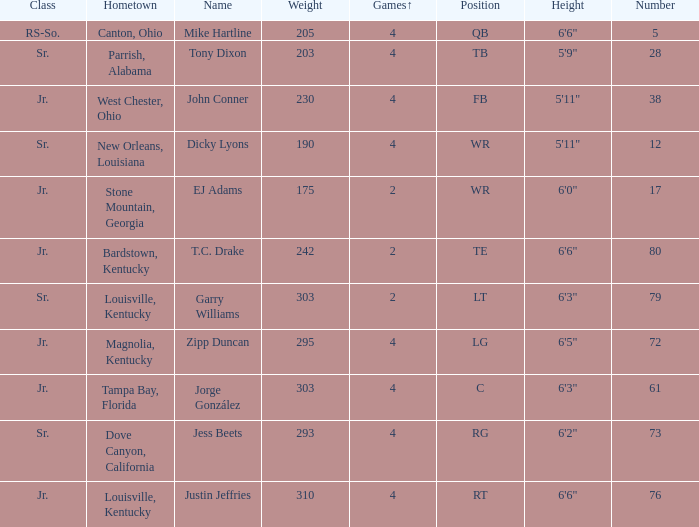Which Class has a Weight of 203? Sr. Write the full table. {'header': ['Class', 'Hometown', 'Name', 'Weight', 'Games↑', 'Position', 'Height', 'Number'], 'rows': [['RS-So.', 'Canton, Ohio', 'Mike Hartline', '205', '4', 'QB', '6\'6"', '5'], ['Sr.', 'Parrish, Alabama', 'Tony Dixon', '203', '4', 'TB', '5\'9"', '28'], ['Jr.', 'West Chester, Ohio', 'John Conner', '230', '4', 'FB', '5\'11"', '38'], ['Sr.', 'New Orleans, Louisiana', 'Dicky Lyons', '190', '4', 'WR', '5\'11"', '12'], ['Jr.', 'Stone Mountain, Georgia', 'EJ Adams', '175', '2', 'WR', '6\'0"', '17'], ['Jr.', 'Bardstown, Kentucky', 'T.C. Drake', '242', '2', 'TE', '6\'6"', '80'], ['Sr.', 'Louisville, Kentucky', 'Garry Williams', '303', '2', 'LT', '6\'3"', '79'], ['Jr.', 'Magnolia, Kentucky', 'Zipp Duncan', '295', '4', 'LG', '6\'5"', '72'], ['Jr.', 'Tampa Bay, Florida', 'Jorge González', '303', '4', 'C', '6\'3"', '61'], ['Sr.', 'Dove Canyon, California', 'Jess Beets', '293', '4', 'RG', '6\'2"', '73'], ['Jr.', 'Louisville, Kentucky', 'Justin Jeffries', '310', '4', 'RT', '6\'6"', '76']]} 